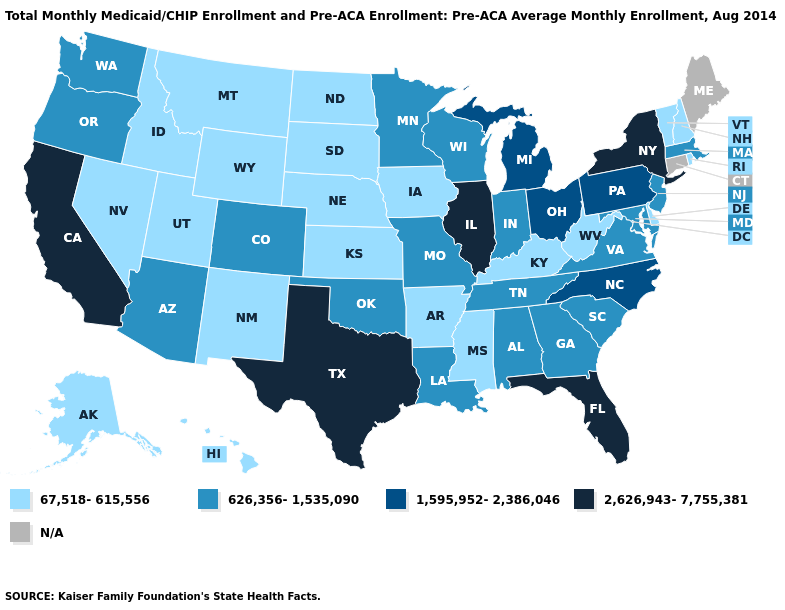Among the states that border New York , does Vermont have the lowest value?
Answer briefly. Yes. What is the highest value in states that border Kentucky?
Answer briefly. 2,626,943-7,755,381. Which states have the highest value in the USA?
Answer briefly. California, Florida, Illinois, New York, Texas. How many symbols are there in the legend?
Keep it brief. 5. What is the lowest value in the USA?
Short answer required. 67,518-615,556. Does Kentucky have the lowest value in the South?
Quick response, please. Yes. Name the states that have a value in the range 2,626,943-7,755,381?
Quick response, please. California, Florida, Illinois, New York, Texas. Among the states that border Maryland , does Delaware have the lowest value?
Quick response, please. Yes. Does Rhode Island have the lowest value in the Northeast?
Quick response, please. Yes. What is the value of Kentucky?
Give a very brief answer. 67,518-615,556. What is the value of Louisiana?
Short answer required. 626,356-1,535,090. Which states have the lowest value in the West?
Concise answer only. Alaska, Hawaii, Idaho, Montana, Nevada, New Mexico, Utah, Wyoming. What is the highest value in the Northeast ?
Be succinct. 2,626,943-7,755,381. Which states have the lowest value in the USA?
Concise answer only. Alaska, Arkansas, Delaware, Hawaii, Idaho, Iowa, Kansas, Kentucky, Mississippi, Montana, Nebraska, Nevada, New Hampshire, New Mexico, North Dakota, Rhode Island, South Dakota, Utah, Vermont, West Virginia, Wyoming. What is the value of Oregon?
Give a very brief answer. 626,356-1,535,090. 